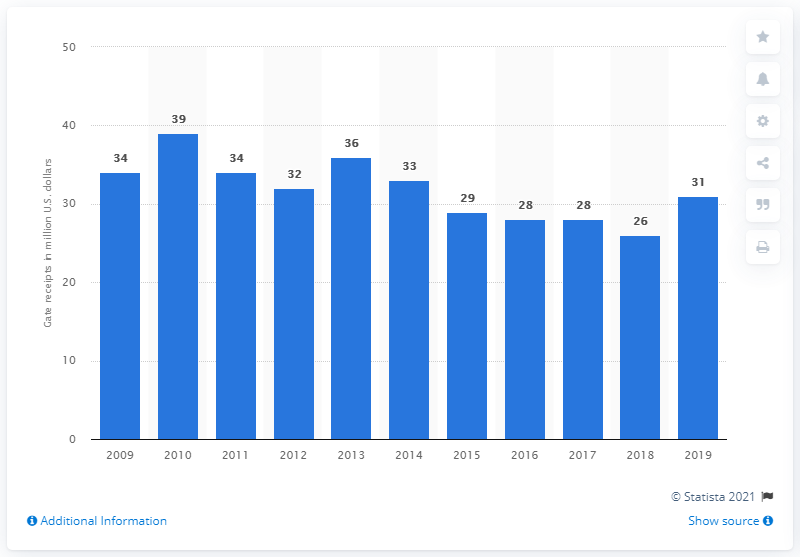Draw attention to some important aspects in this diagram. The gate receipts of the Tampa Bay Rays in 2019 were 31... 